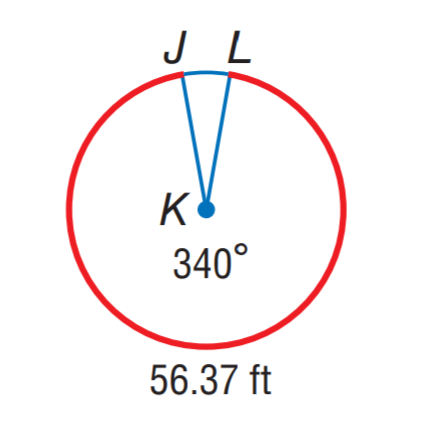Question: Find the radius of \odot K. Round to the nearest hundredth.
Choices:
A. 9.50
B. 19.00
C. 56.37
D. 59.69
Answer with the letter. Answer: B 